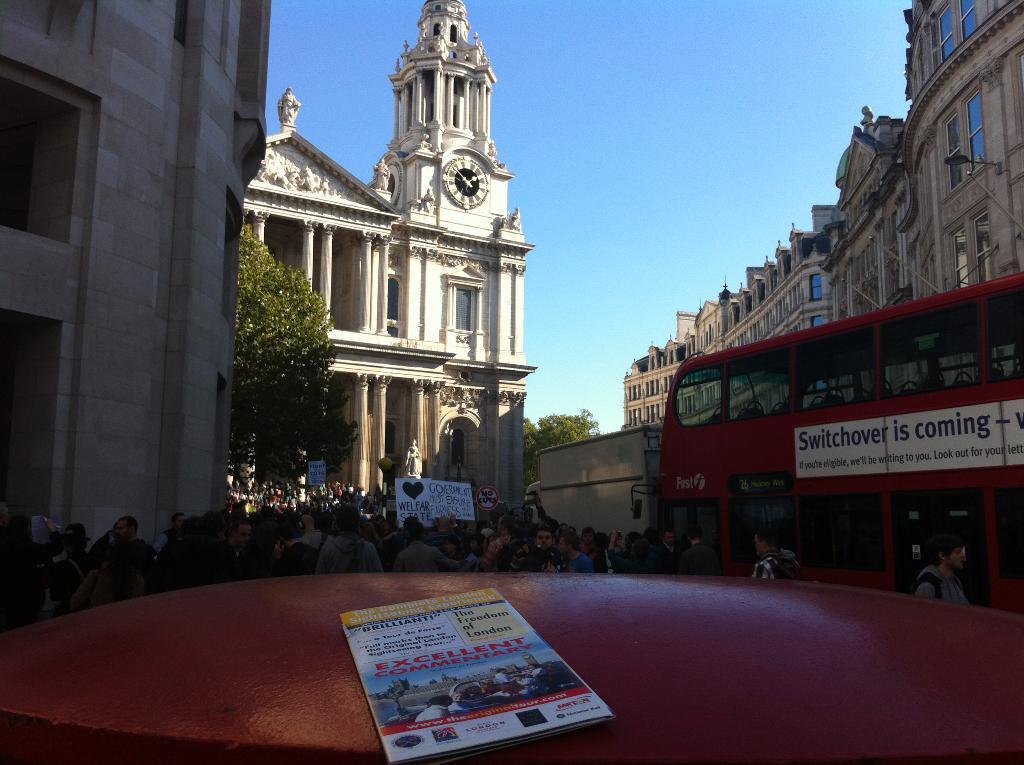Please provide a concise description of this image. At the top of the image we can see buildings, clock tower, trees, sky and persons. At the top of the image we can see a motor vehicle and a book placed on the wall. 